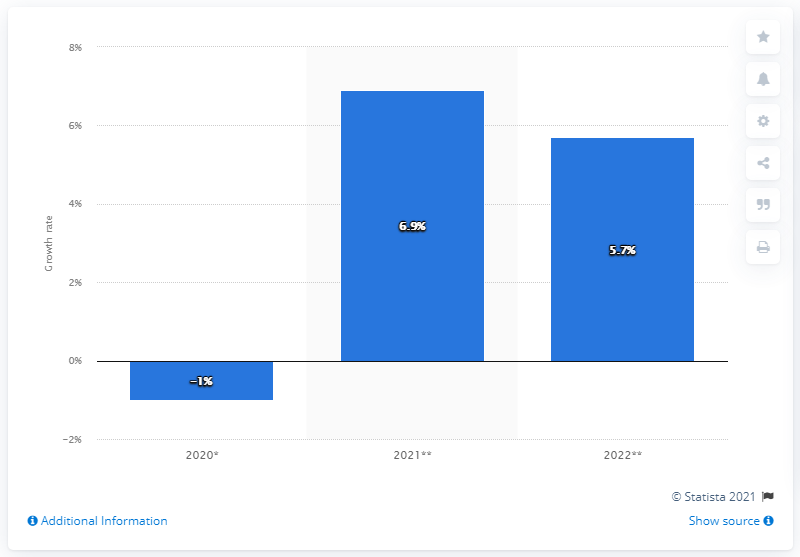Highlight a few significant elements in this photo. The expected growth of Kenya's GDP in 2021 is projected to be 6.9%. 